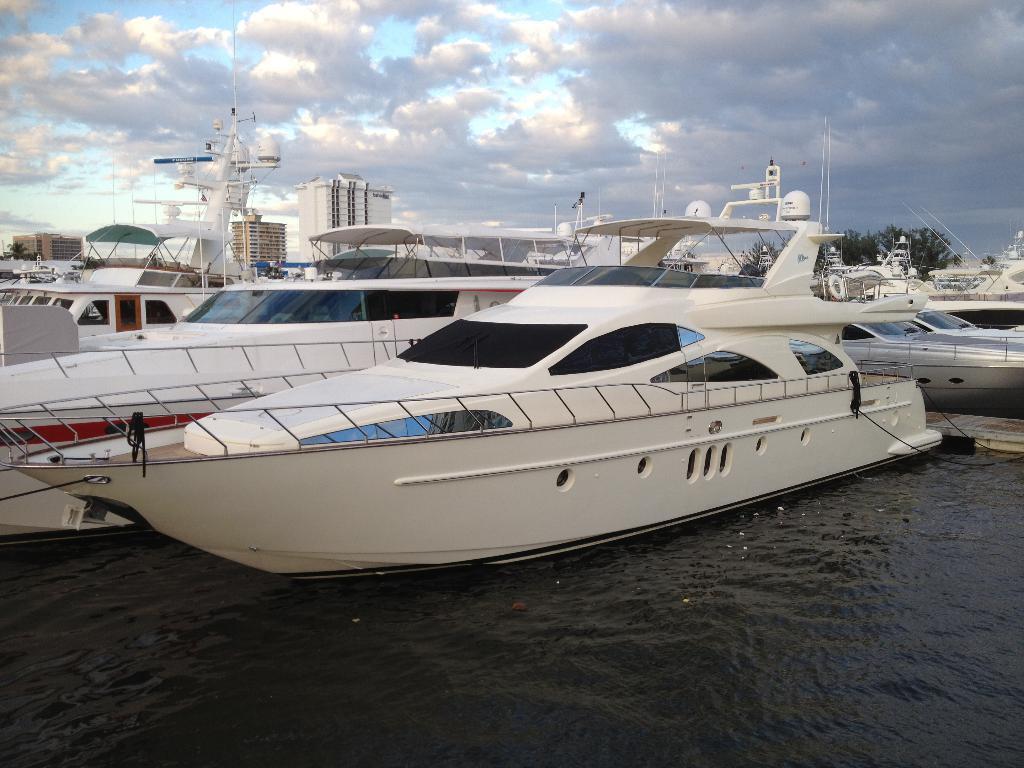Can you describe this image briefly? We can see boats above the water and poles. In the background we can see buildings, trees and sky with clouds. 